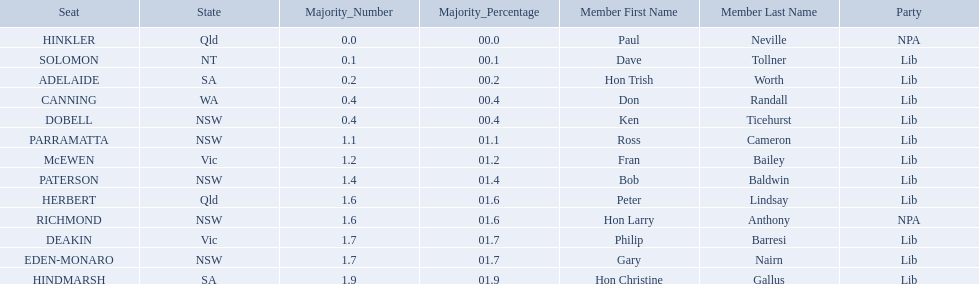Parse the full table in json format. {'header': ['Seat', 'State', 'Majority_Number', 'Majority_Percentage', 'Member First Name', 'Member Last Name', 'Party'], 'rows': [['HINKLER', 'Qld', '0.0', '00.0', 'Paul', 'Neville', 'NPA'], ['SOLOMON', 'NT', '0.1', '00.1', 'Dave', 'Tollner', 'Lib'], ['ADELAIDE', 'SA', '0.2', '00.2', 'Hon Trish', 'Worth', 'Lib'], ['CANNING', 'WA', '0.4', '00.4', 'Don', 'Randall', 'Lib'], ['DOBELL', 'NSW', '0.4', '00.4', 'Ken', 'Ticehurst', 'Lib'], ['PARRAMATTA', 'NSW', '1.1', '01.1', 'Ross', 'Cameron', 'Lib'], ['McEWEN', 'Vic', '1.2', '01.2', 'Fran', 'Bailey', 'Lib'], ['PATERSON', 'NSW', '1.4', '01.4', 'Bob', 'Baldwin', 'Lib'], ['HERBERT', 'Qld', '1.6', '01.6', 'Peter', 'Lindsay', 'Lib'], ['RICHMOND', 'NSW', '1.6', '01.6', 'Hon Larry', 'Anthony', 'NPA'], ['DEAKIN', 'Vic', '1.7', '01.7', 'Philip', 'Barresi', 'Lib'], ['EDEN-MONARO', 'NSW', '1.7', '01.7', 'Gary', 'Nairn', 'Lib'], ['HINDMARSH', 'SA', '1.9', '01.9', 'Hon Christine', 'Gallus', 'Lib']]} What state does hinkler belong too? Qld. What is the majority of difference between sa and qld? 01.9. 